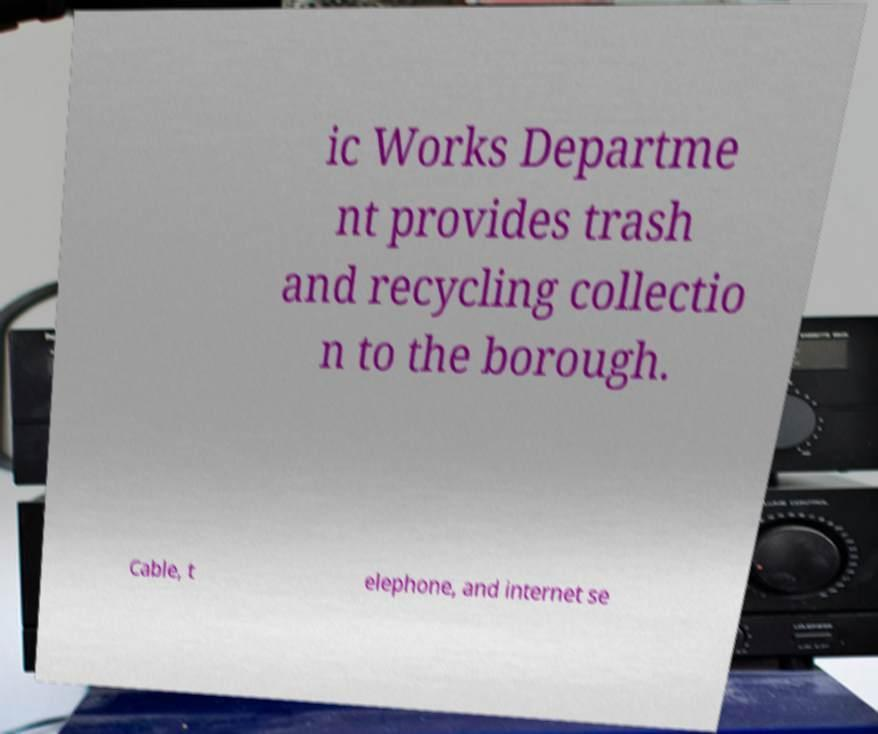There's text embedded in this image that I need extracted. Can you transcribe it verbatim? ic Works Departme nt provides trash and recycling collectio n to the borough. Cable, t elephone, and internet se 